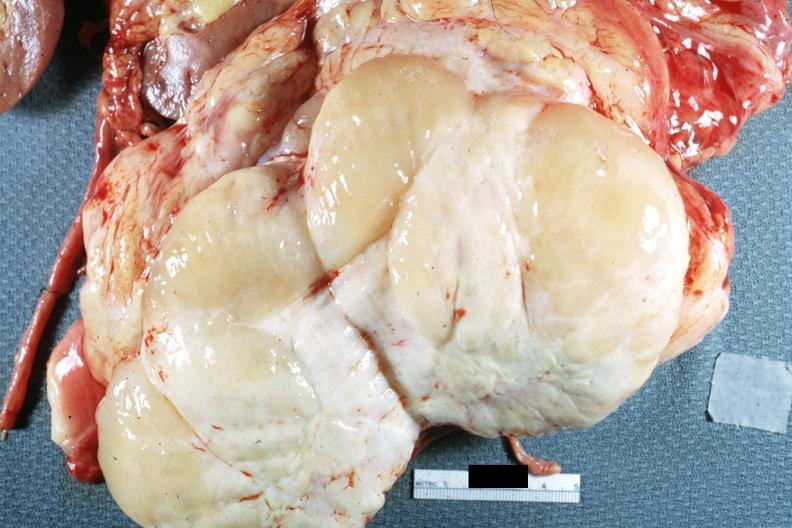how is nodular tumor cut surface color yellow and white typical gross sarcoma?
Answer the question using a single word or phrase. Natural 